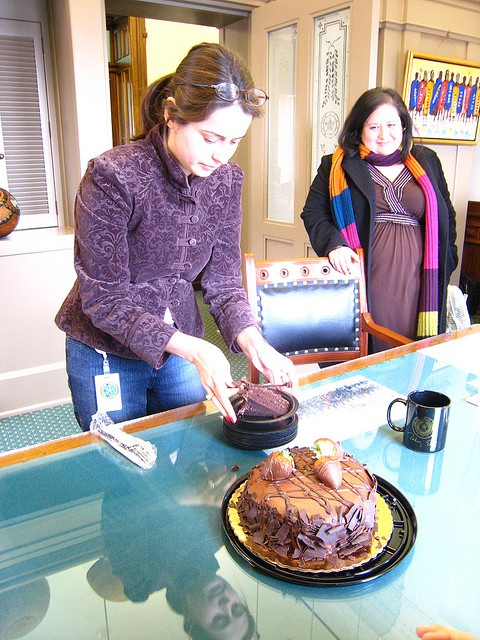Describe the objects in this image and their specific colors. I can see dining table in gray, white, teal, darkgray, and lightblue tones, people in gray, white, and purple tones, people in gray, black, purple, and white tones, cake in gray, lavender, brown, maroon, and tan tones, and chair in gray, white, and lightblue tones in this image. 